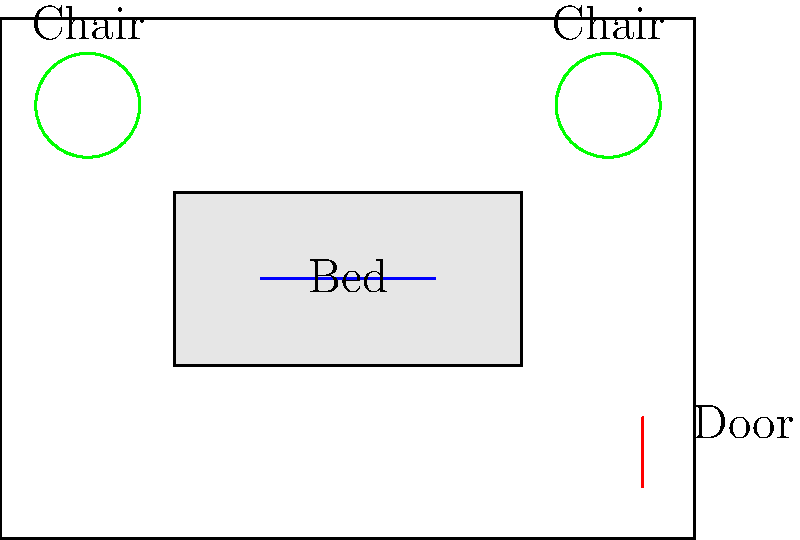In a children's hospital, you're designing a room layout with a bed, two chairs, and a door. How many unique arrangements are possible if the bed must always be against a wall, the chairs must be on opposite sides of the room, and the door location is fixed? Let's approach this step-by-step:

1) First, we need to consider the constraints:
   - The bed must be against a wall
   - The chairs must be on opposite sides of the room
   - The door location is fixed

2) For the bed, we have 4 walls to choose from. This gives us 4 options.

3) Once the bed is placed, we need to consider the chair placements:
   - If the bed is on a long wall (2 possibilities), we have 2 ways to place the chairs on the opposite walls
   - If the bed is on a short wall (2 possibilities), we again have 2 ways to place the chairs on the opposite walls

4) This gives us a total of:
   $$(2 \times 2) + (2 \times 2) = 8$$

5) The door's location is fixed, so it doesn't affect our calculation.

6) Therefore, the total number of unique arrangements is 8.

This problem relates to permutation groups because we're dealing with different arrangements (permutations) of objects (bed and chairs) within certain constraints. The fixed door and the constraints on bed and chair placements reduce the total number of permutations from what would be possible if all objects could be placed anywhere.
Answer: 8 unique arrangements 